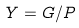Convert formula to latex. <formula><loc_0><loc_0><loc_500><loc_500>Y = G / P</formula> 